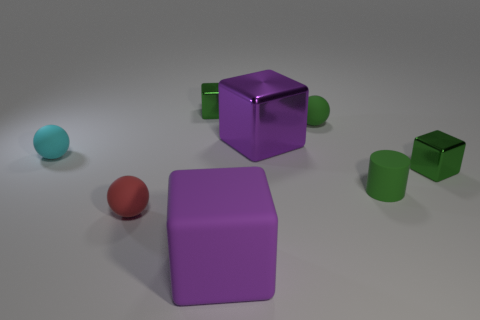Are there any other things that are the same color as the rubber cylinder?
Provide a succinct answer. Yes. Is the material of the purple block that is in front of the tiny cyan rubber object the same as the cylinder?
Provide a succinct answer. Yes. How many small blocks are both behind the tiny cyan thing and right of the cylinder?
Your answer should be very brief. 0. How big is the green metal thing that is in front of the small green block behind the small cyan matte thing?
Ensure brevity in your answer.  Small. Is there anything else that is the same material as the tiny cylinder?
Offer a terse response. Yes. Are there more cylinders than large gray things?
Offer a terse response. Yes. Do the shiny object that is to the right of the large metal cube and the object in front of the tiny red rubber sphere have the same color?
Ensure brevity in your answer.  No. There is a big block behind the big purple matte cube; are there any metal things to the left of it?
Your answer should be compact. Yes. Is the number of red matte objects that are behind the tiny cyan rubber sphere less than the number of objects that are on the left side of the tiny matte cylinder?
Make the answer very short. Yes. Is the large cube in front of the red matte thing made of the same material as the large purple thing that is behind the small red matte sphere?
Keep it short and to the point. No. 